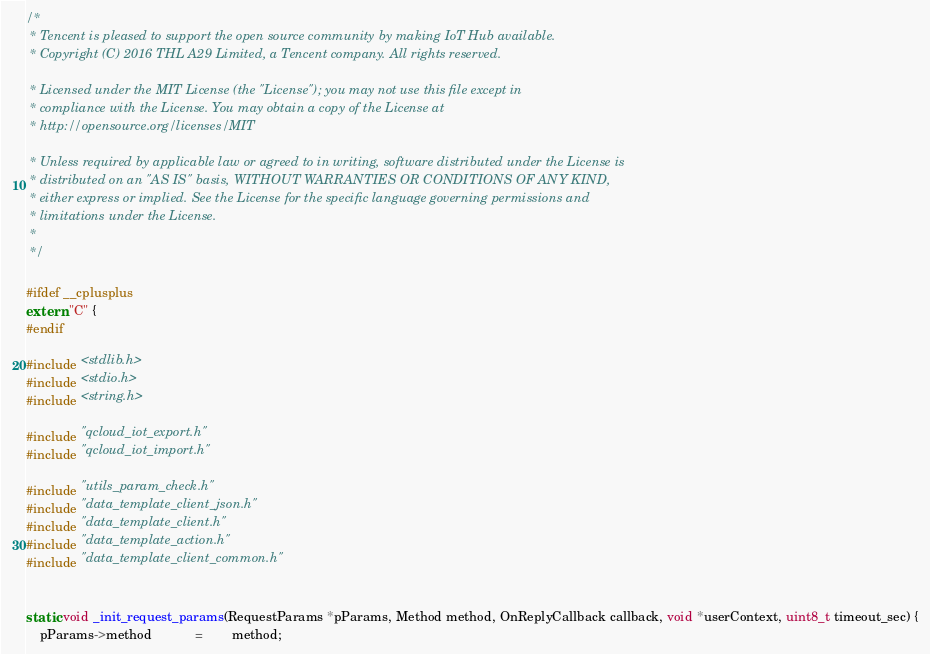Convert code to text. <code><loc_0><loc_0><loc_500><loc_500><_C_>/*
 * Tencent is pleased to support the open source community by making IoT Hub available.
 * Copyright (C) 2016 THL A29 Limited, a Tencent company. All rights reserved.

 * Licensed under the MIT License (the "License"); you may not use this file except in
 * compliance with the License. You may obtain a copy of the License at
 * http://opensource.org/licenses/MIT

 * Unless required by applicable law or agreed to in writing, software distributed under the License is
 * distributed on an "AS IS" basis, WITHOUT WARRANTIES OR CONDITIONS OF ANY KIND,
 * either express or implied. See the License for the specific language governing permissions and
 * limitations under the License.
 *
 */

#ifdef __cplusplus
extern "C" {
#endif

#include <stdlib.h>
#include <stdio.h>
#include <string.h>

#include "qcloud_iot_export.h"
#include "qcloud_iot_import.h"

#include "utils_param_check.h"
#include "data_template_client_json.h"
#include "data_template_client.h"
#include "data_template_action.h"
#include "data_template_client_common.h"


static void _init_request_params(RequestParams *pParams, Method method, OnReplyCallback callback, void *userContext, uint8_t timeout_sec) {
	pParams->method 			=		method;</code> 